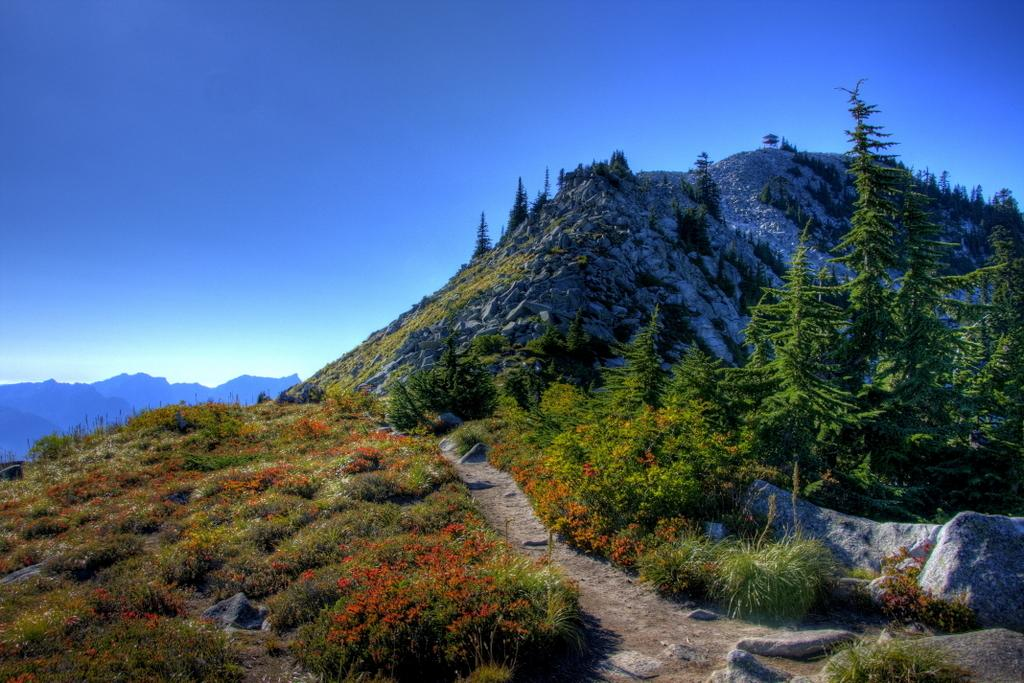What type of vegetation can be seen in the image? There are small plants, shrubs, and grass in the image. Is there any indication of a path or way in the image? Yes, there is a path or way in the image. What other natural elements can be seen in the image? There are rocks and hills in the image. What is the color of the sky in the background of the image? The sky is blue in the background of the image. What type of pie is being sold at the market in the image? There is no market or pie present in the image; it features a natural landscape with vegetation, rocks, hills, and a blue sky. How many balls are visible in the image? There are no balls present in the image. 